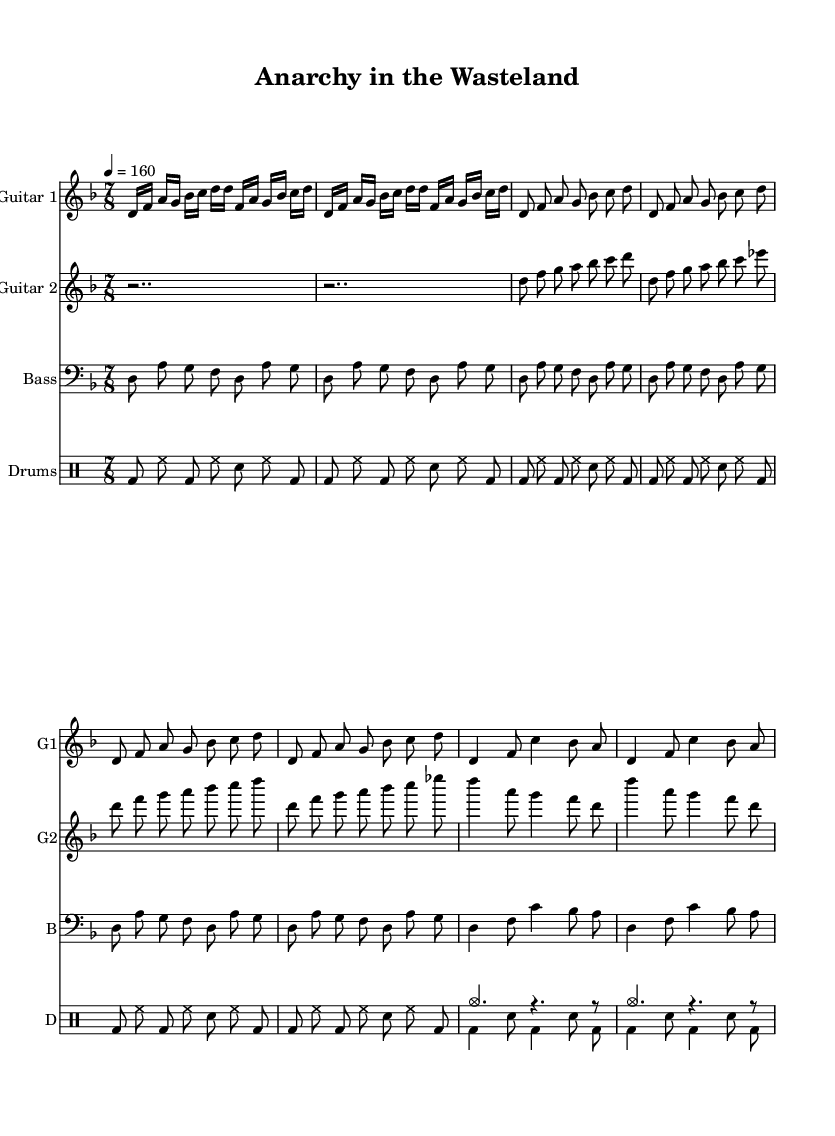What is the key signature of this music? The key signature is D minor, which has one flat (B flat). We can identify this by looking at the key signature indicator placed at the beginning of the staff.
Answer: D minor What is the time signature of this music? The time signature is seven eighths, as indicated at the start of the score. This shows that each measure consists of seven eighth notes.
Answer: 7/8 What is the tempo marking for this piece? The tempo marking is quarter note equals 160, shown at the beginning of the sheet music. This indicates that there are 160 quarter note beats per minute.
Answer: 160 How many measures are in the intro section for Guitar 1? Guitar 1's intro section is repeated twice, and it consists of 4 measures when counted individually. Thus, the total for the intro is 4 measures.
Answer: 4 measures Which instruments are part of this score? The score includes two guitars, a bass guitar, and drums. This information can be found in the separate parts labeled at the beginning of each staff.
Answer: Two guitars, bass, drums What is the rhythmic pattern used in the drum part during the basic pattern? The rhythmic pattern for the basic drum part consists of a kick drum on the downbeat followed by hi-hat and snare in alternation for six measures. This consistent pattern creates a driving rhythm typical in thrash metal.
Answer: Kick and hi-hat alternating Identify the tonal range of the bass guitar notes during the intro and verse. In the intro and verse sections, the bass guitar part mainly revolves around D in the lower octave and A in the higher octave, reflecting the D minor tonality. This can be determined by analyzing the notes played in these sections.
Answer: D and A 